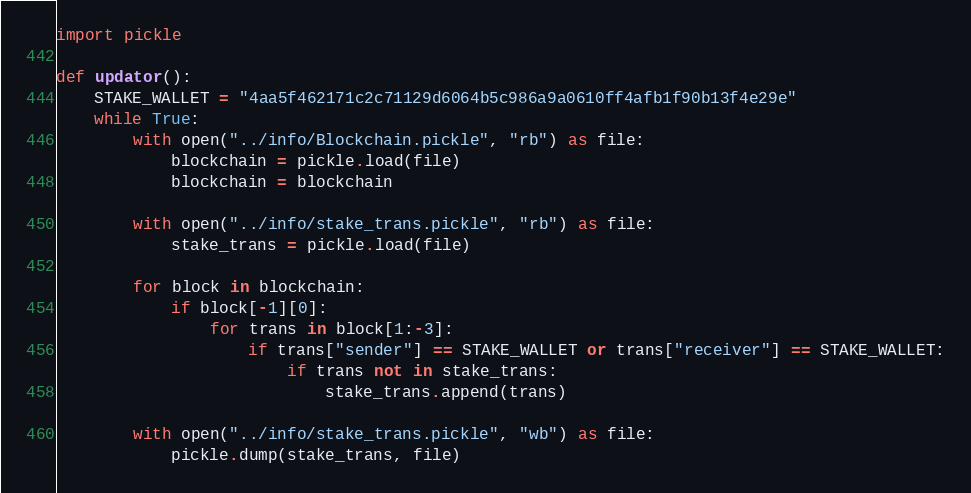Convert code to text. <code><loc_0><loc_0><loc_500><loc_500><_Python_>import pickle

def updator():
    STAKE_WALLET = "4aa5f462171c2c71129d6064b5c986a9a0610ff4afb1f90b13f4e29e"
    while True:
        with open("../info/Blockchain.pickle", "rb") as file:
            blockchain = pickle.load(file)
            blockchain = blockchain

        with open("../info/stake_trans.pickle", "rb") as file:
            stake_trans = pickle.load(file)

        for block in blockchain:
            if block[-1][0]:
                for trans in block[1:-3]:
                    if trans["sender"] == STAKE_WALLET or trans["receiver"] == STAKE_WALLET:
                        if trans not in stake_trans:
                            stake_trans.append(trans)

        with open("../info/stake_trans.pickle", "wb") as file:
            pickle.dump(stake_trans, file)



</code> 